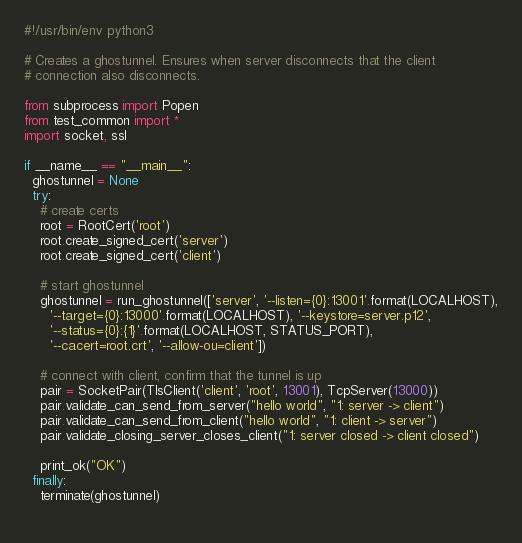<code> <loc_0><loc_0><loc_500><loc_500><_Python_>#!/usr/bin/env python3

# Creates a ghostunnel. Ensures when server disconnects that the client
# connection also disconnects.

from subprocess import Popen
from test_common import *
import socket, ssl

if __name__ == "__main__":
  ghostunnel = None
  try:
    # create certs
    root = RootCert('root')
    root.create_signed_cert('server')
    root.create_signed_cert('client')

    # start ghostunnel
    ghostunnel = run_ghostunnel(['server', '--listen={0}:13001'.format(LOCALHOST),
      '--target={0}:13000'.format(LOCALHOST), '--keystore=server.p12',
      '--status={0}:{1}'.format(LOCALHOST, STATUS_PORT),
      '--cacert=root.crt', '--allow-ou=client'])

    # connect with client, confirm that the tunnel is up
    pair = SocketPair(TlsClient('client', 'root', 13001), TcpServer(13000))
    pair.validate_can_send_from_server("hello world", "1: server -> client")
    pair.validate_can_send_from_client("hello world", "1: client -> server")
    pair.validate_closing_server_closes_client("1: server closed -> client closed")

    print_ok("OK")
  finally:
    terminate(ghostunnel)
      
</code> 